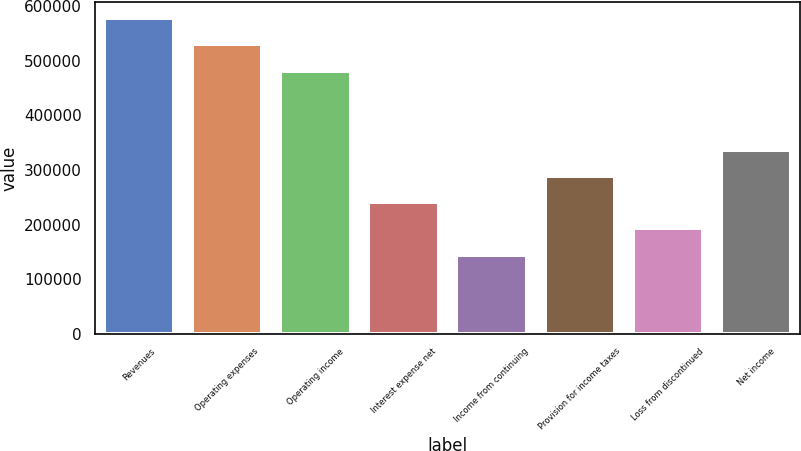Convert chart to OTSL. <chart><loc_0><loc_0><loc_500><loc_500><bar_chart><fcel>Revenues<fcel>Operating expenses<fcel>Operating income<fcel>Interest expense net<fcel>Income from continuing<fcel>Provision for income taxes<fcel>Loss from discontinued<fcel>Net income<nl><fcel>578184<fcel>530002<fcel>481820<fcel>240910<fcel>144546<fcel>289092<fcel>192728<fcel>337274<nl></chart> 